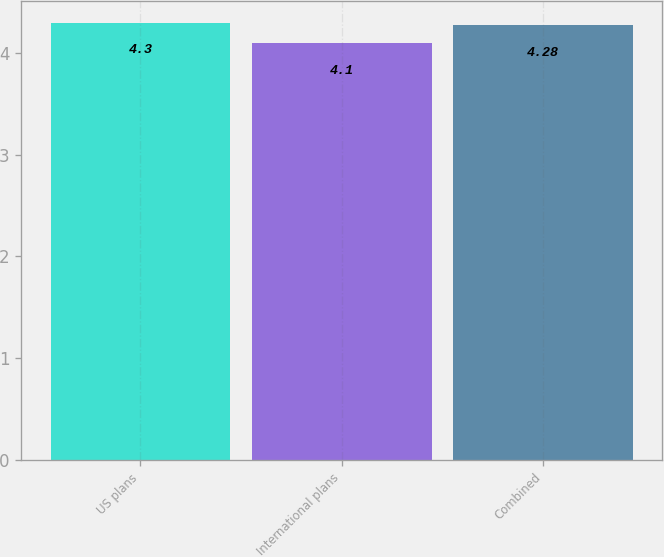Convert chart. <chart><loc_0><loc_0><loc_500><loc_500><bar_chart><fcel>US plans<fcel>International plans<fcel>Combined<nl><fcel>4.3<fcel>4.1<fcel>4.28<nl></chart> 